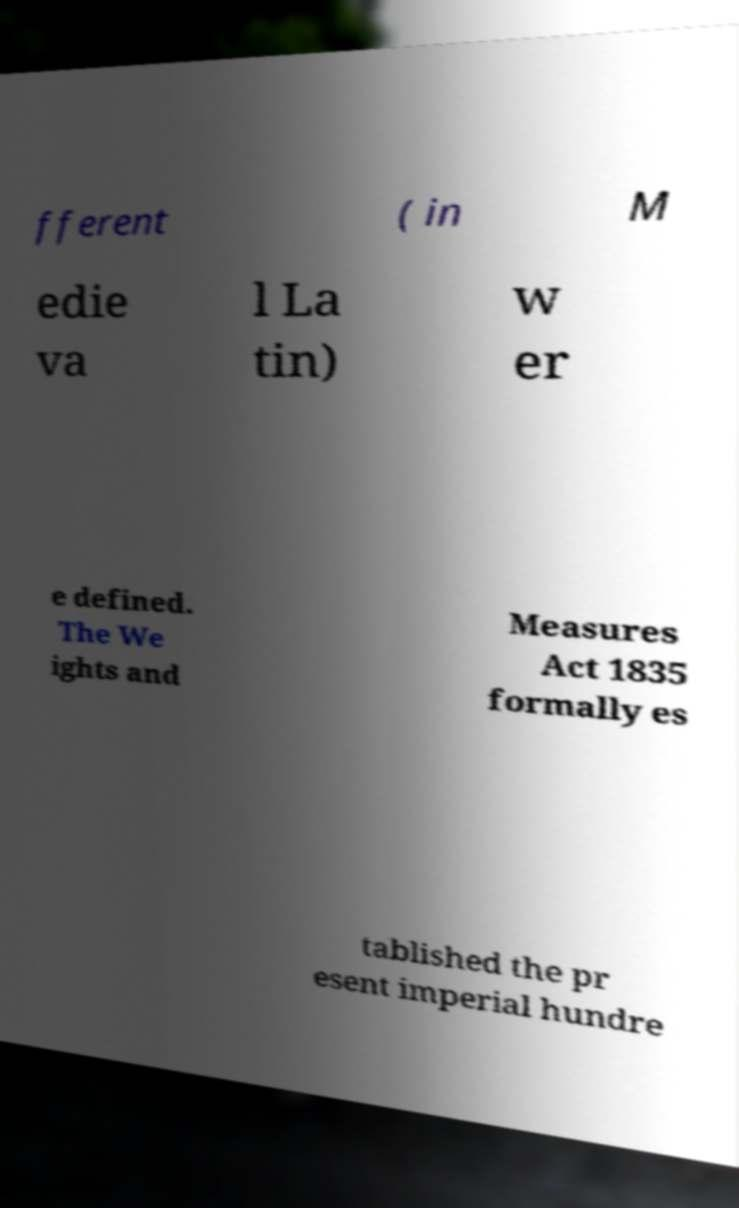Could you extract and type out the text from this image? fferent ( in M edie va l La tin) w er e defined. The We ights and Measures Act 1835 formally es tablished the pr esent imperial hundre 